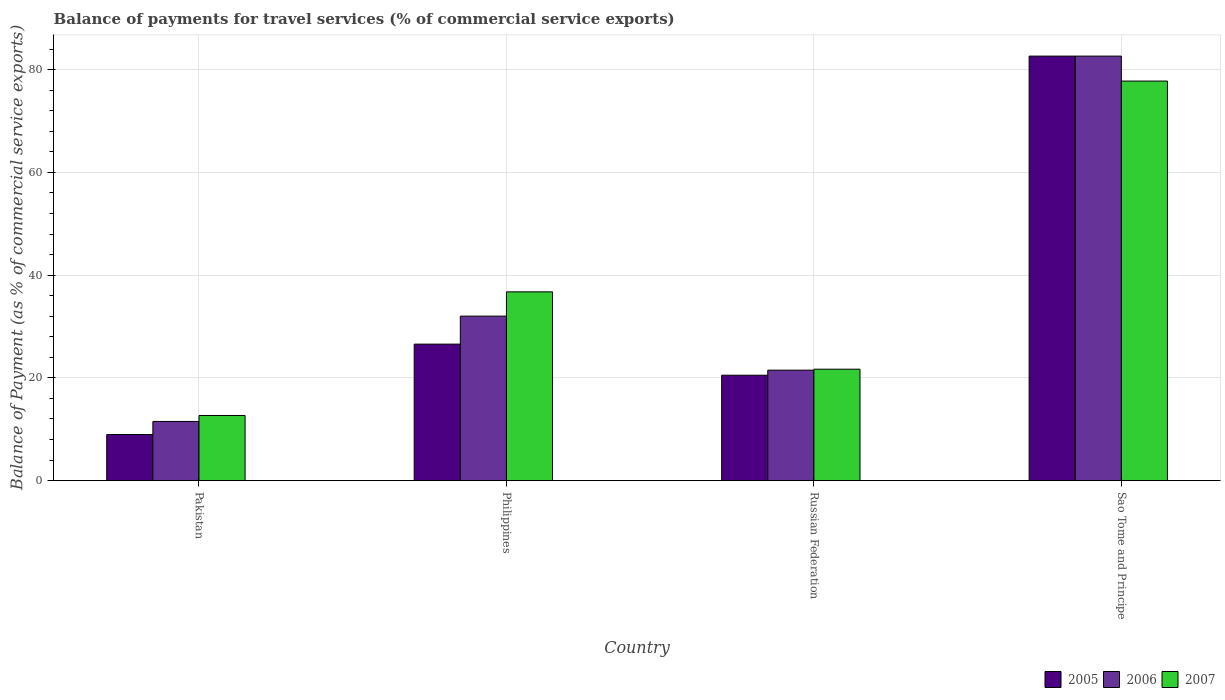How many groups of bars are there?
Provide a succinct answer. 4. Are the number of bars per tick equal to the number of legend labels?
Make the answer very short. Yes. Are the number of bars on each tick of the X-axis equal?
Make the answer very short. Yes. What is the balance of payments for travel services in 2007 in Russian Federation?
Keep it short and to the point. 21.69. Across all countries, what is the maximum balance of payments for travel services in 2005?
Keep it short and to the point. 82.64. Across all countries, what is the minimum balance of payments for travel services in 2007?
Make the answer very short. 12.67. In which country was the balance of payments for travel services in 2006 maximum?
Keep it short and to the point. Sao Tome and Principe. In which country was the balance of payments for travel services in 2007 minimum?
Keep it short and to the point. Pakistan. What is the total balance of payments for travel services in 2006 in the graph?
Your answer should be compact. 147.67. What is the difference between the balance of payments for travel services in 2005 in Philippines and that in Sao Tome and Principe?
Give a very brief answer. -56.08. What is the difference between the balance of payments for travel services in 2005 in Russian Federation and the balance of payments for travel services in 2006 in Sao Tome and Principe?
Offer a terse response. -62.13. What is the average balance of payments for travel services in 2007 per country?
Offer a terse response. 37.22. What is the difference between the balance of payments for travel services of/in 2006 and balance of payments for travel services of/in 2005 in Philippines?
Your response must be concise. 5.45. In how many countries, is the balance of payments for travel services in 2006 greater than 60 %?
Offer a terse response. 1. What is the ratio of the balance of payments for travel services in 2005 in Pakistan to that in Russian Federation?
Keep it short and to the point. 0.44. Is the difference between the balance of payments for travel services in 2006 in Russian Federation and Sao Tome and Principe greater than the difference between the balance of payments for travel services in 2005 in Russian Federation and Sao Tome and Principe?
Offer a terse response. Yes. What is the difference between the highest and the second highest balance of payments for travel services in 2007?
Ensure brevity in your answer.  -15.06. What is the difference between the highest and the lowest balance of payments for travel services in 2007?
Provide a succinct answer. 65.11. In how many countries, is the balance of payments for travel services in 2007 greater than the average balance of payments for travel services in 2007 taken over all countries?
Your answer should be compact. 1. What does the 1st bar from the left in Russian Federation represents?
Give a very brief answer. 2005. Is it the case that in every country, the sum of the balance of payments for travel services in 2006 and balance of payments for travel services in 2005 is greater than the balance of payments for travel services in 2007?
Provide a succinct answer. Yes. How many bars are there?
Give a very brief answer. 12. Does the graph contain any zero values?
Provide a short and direct response. No. How many legend labels are there?
Give a very brief answer. 3. How are the legend labels stacked?
Give a very brief answer. Horizontal. What is the title of the graph?
Give a very brief answer. Balance of payments for travel services (% of commercial service exports). What is the label or title of the Y-axis?
Your answer should be very brief. Balance of Payment (as % of commercial service exports). What is the Balance of Payment (as % of commercial service exports) of 2005 in Pakistan?
Offer a terse response. 8.97. What is the Balance of Payment (as % of commercial service exports) in 2006 in Pakistan?
Make the answer very short. 11.51. What is the Balance of Payment (as % of commercial service exports) of 2007 in Pakistan?
Give a very brief answer. 12.67. What is the Balance of Payment (as % of commercial service exports) in 2005 in Philippines?
Offer a terse response. 26.56. What is the Balance of Payment (as % of commercial service exports) of 2006 in Philippines?
Provide a short and direct response. 32.02. What is the Balance of Payment (as % of commercial service exports) in 2007 in Philippines?
Provide a succinct answer. 36.74. What is the Balance of Payment (as % of commercial service exports) of 2005 in Russian Federation?
Give a very brief answer. 20.51. What is the Balance of Payment (as % of commercial service exports) of 2006 in Russian Federation?
Ensure brevity in your answer.  21.5. What is the Balance of Payment (as % of commercial service exports) of 2007 in Russian Federation?
Provide a short and direct response. 21.69. What is the Balance of Payment (as % of commercial service exports) in 2005 in Sao Tome and Principe?
Offer a very short reply. 82.64. What is the Balance of Payment (as % of commercial service exports) of 2006 in Sao Tome and Principe?
Your answer should be compact. 82.64. What is the Balance of Payment (as % of commercial service exports) of 2007 in Sao Tome and Principe?
Ensure brevity in your answer.  77.78. Across all countries, what is the maximum Balance of Payment (as % of commercial service exports) of 2005?
Your answer should be very brief. 82.64. Across all countries, what is the maximum Balance of Payment (as % of commercial service exports) in 2006?
Offer a terse response. 82.64. Across all countries, what is the maximum Balance of Payment (as % of commercial service exports) of 2007?
Your answer should be very brief. 77.78. Across all countries, what is the minimum Balance of Payment (as % of commercial service exports) in 2005?
Your answer should be compact. 8.97. Across all countries, what is the minimum Balance of Payment (as % of commercial service exports) in 2006?
Keep it short and to the point. 11.51. Across all countries, what is the minimum Balance of Payment (as % of commercial service exports) in 2007?
Ensure brevity in your answer.  12.67. What is the total Balance of Payment (as % of commercial service exports) of 2005 in the graph?
Keep it short and to the point. 138.68. What is the total Balance of Payment (as % of commercial service exports) of 2006 in the graph?
Your answer should be compact. 147.67. What is the total Balance of Payment (as % of commercial service exports) in 2007 in the graph?
Ensure brevity in your answer.  148.89. What is the difference between the Balance of Payment (as % of commercial service exports) in 2005 in Pakistan and that in Philippines?
Your response must be concise. -17.6. What is the difference between the Balance of Payment (as % of commercial service exports) in 2006 in Pakistan and that in Philippines?
Your answer should be very brief. -20.5. What is the difference between the Balance of Payment (as % of commercial service exports) of 2007 in Pakistan and that in Philippines?
Ensure brevity in your answer.  -24.07. What is the difference between the Balance of Payment (as % of commercial service exports) of 2005 in Pakistan and that in Russian Federation?
Ensure brevity in your answer.  -11.55. What is the difference between the Balance of Payment (as % of commercial service exports) of 2006 in Pakistan and that in Russian Federation?
Give a very brief answer. -9.98. What is the difference between the Balance of Payment (as % of commercial service exports) in 2007 in Pakistan and that in Russian Federation?
Offer a very short reply. -9.01. What is the difference between the Balance of Payment (as % of commercial service exports) of 2005 in Pakistan and that in Sao Tome and Principe?
Give a very brief answer. -73.68. What is the difference between the Balance of Payment (as % of commercial service exports) of 2006 in Pakistan and that in Sao Tome and Principe?
Keep it short and to the point. -71.13. What is the difference between the Balance of Payment (as % of commercial service exports) of 2007 in Pakistan and that in Sao Tome and Principe?
Your answer should be compact. -65.11. What is the difference between the Balance of Payment (as % of commercial service exports) of 2005 in Philippines and that in Russian Federation?
Provide a short and direct response. 6.05. What is the difference between the Balance of Payment (as % of commercial service exports) in 2006 in Philippines and that in Russian Federation?
Ensure brevity in your answer.  10.52. What is the difference between the Balance of Payment (as % of commercial service exports) of 2007 in Philippines and that in Russian Federation?
Keep it short and to the point. 15.06. What is the difference between the Balance of Payment (as % of commercial service exports) of 2005 in Philippines and that in Sao Tome and Principe?
Ensure brevity in your answer.  -56.08. What is the difference between the Balance of Payment (as % of commercial service exports) in 2006 in Philippines and that in Sao Tome and Principe?
Provide a short and direct response. -50.63. What is the difference between the Balance of Payment (as % of commercial service exports) of 2007 in Philippines and that in Sao Tome and Principe?
Offer a terse response. -41.04. What is the difference between the Balance of Payment (as % of commercial service exports) in 2005 in Russian Federation and that in Sao Tome and Principe?
Keep it short and to the point. -62.13. What is the difference between the Balance of Payment (as % of commercial service exports) in 2006 in Russian Federation and that in Sao Tome and Principe?
Give a very brief answer. -61.15. What is the difference between the Balance of Payment (as % of commercial service exports) in 2007 in Russian Federation and that in Sao Tome and Principe?
Your response must be concise. -56.1. What is the difference between the Balance of Payment (as % of commercial service exports) in 2005 in Pakistan and the Balance of Payment (as % of commercial service exports) in 2006 in Philippines?
Give a very brief answer. -23.05. What is the difference between the Balance of Payment (as % of commercial service exports) of 2005 in Pakistan and the Balance of Payment (as % of commercial service exports) of 2007 in Philippines?
Provide a succinct answer. -27.78. What is the difference between the Balance of Payment (as % of commercial service exports) in 2006 in Pakistan and the Balance of Payment (as % of commercial service exports) in 2007 in Philippines?
Offer a very short reply. -25.23. What is the difference between the Balance of Payment (as % of commercial service exports) of 2005 in Pakistan and the Balance of Payment (as % of commercial service exports) of 2006 in Russian Federation?
Make the answer very short. -12.53. What is the difference between the Balance of Payment (as % of commercial service exports) of 2005 in Pakistan and the Balance of Payment (as % of commercial service exports) of 2007 in Russian Federation?
Give a very brief answer. -12.72. What is the difference between the Balance of Payment (as % of commercial service exports) in 2006 in Pakistan and the Balance of Payment (as % of commercial service exports) in 2007 in Russian Federation?
Offer a very short reply. -10.17. What is the difference between the Balance of Payment (as % of commercial service exports) of 2005 in Pakistan and the Balance of Payment (as % of commercial service exports) of 2006 in Sao Tome and Principe?
Your answer should be compact. -73.68. What is the difference between the Balance of Payment (as % of commercial service exports) of 2005 in Pakistan and the Balance of Payment (as % of commercial service exports) of 2007 in Sao Tome and Principe?
Your answer should be compact. -68.82. What is the difference between the Balance of Payment (as % of commercial service exports) in 2006 in Pakistan and the Balance of Payment (as % of commercial service exports) in 2007 in Sao Tome and Principe?
Keep it short and to the point. -66.27. What is the difference between the Balance of Payment (as % of commercial service exports) in 2005 in Philippines and the Balance of Payment (as % of commercial service exports) in 2006 in Russian Federation?
Offer a terse response. 5.07. What is the difference between the Balance of Payment (as % of commercial service exports) in 2005 in Philippines and the Balance of Payment (as % of commercial service exports) in 2007 in Russian Federation?
Make the answer very short. 4.88. What is the difference between the Balance of Payment (as % of commercial service exports) in 2006 in Philippines and the Balance of Payment (as % of commercial service exports) in 2007 in Russian Federation?
Provide a short and direct response. 10.33. What is the difference between the Balance of Payment (as % of commercial service exports) in 2005 in Philippines and the Balance of Payment (as % of commercial service exports) in 2006 in Sao Tome and Principe?
Keep it short and to the point. -56.08. What is the difference between the Balance of Payment (as % of commercial service exports) in 2005 in Philippines and the Balance of Payment (as % of commercial service exports) in 2007 in Sao Tome and Principe?
Give a very brief answer. -51.22. What is the difference between the Balance of Payment (as % of commercial service exports) in 2006 in Philippines and the Balance of Payment (as % of commercial service exports) in 2007 in Sao Tome and Principe?
Your answer should be very brief. -45.77. What is the difference between the Balance of Payment (as % of commercial service exports) in 2005 in Russian Federation and the Balance of Payment (as % of commercial service exports) in 2006 in Sao Tome and Principe?
Provide a short and direct response. -62.13. What is the difference between the Balance of Payment (as % of commercial service exports) of 2005 in Russian Federation and the Balance of Payment (as % of commercial service exports) of 2007 in Sao Tome and Principe?
Your answer should be very brief. -57.27. What is the difference between the Balance of Payment (as % of commercial service exports) in 2006 in Russian Federation and the Balance of Payment (as % of commercial service exports) in 2007 in Sao Tome and Principe?
Your response must be concise. -56.29. What is the average Balance of Payment (as % of commercial service exports) of 2005 per country?
Provide a succinct answer. 34.67. What is the average Balance of Payment (as % of commercial service exports) in 2006 per country?
Ensure brevity in your answer.  36.92. What is the average Balance of Payment (as % of commercial service exports) in 2007 per country?
Your answer should be very brief. 37.22. What is the difference between the Balance of Payment (as % of commercial service exports) of 2005 and Balance of Payment (as % of commercial service exports) of 2006 in Pakistan?
Make the answer very short. -2.55. What is the difference between the Balance of Payment (as % of commercial service exports) of 2005 and Balance of Payment (as % of commercial service exports) of 2007 in Pakistan?
Your answer should be compact. -3.71. What is the difference between the Balance of Payment (as % of commercial service exports) in 2006 and Balance of Payment (as % of commercial service exports) in 2007 in Pakistan?
Your answer should be very brief. -1.16. What is the difference between the Balance of Payment (as % of commercial service exports) in 2005 and Balance of Payment (as % of commercial service exports) in 2006 in Philippines?
Your answer should be compact. -5.45. What is the difference between the Balance of Payment (as % of commercial service exports) of 2005 and Balance of Payment (as % of commercial service exports) of 2007 in Philippines?
Provide a succinct answer. -10.18. What is the difference between the Balance of Payment (as % of commercial service exports) of 2006 and Balance of Payment (as % of commercial service exports) of 2007 in Philippines?
Provide a short and direct response. -4.73. What is the difference between the Balance of Payment (as % of commercial service exports) in 2005 and Balance of Payment (as % of commercial service exports) in 2006 in Russian Federation?
Offer a very short reply. -0.99. What is the difference between the Balance of Payment (as % of commercial service exports) of 2005 and Balance of Payment (as % of commercial service exports) of 2007 in Russian Federation?
Provide a short and direct response. -1.17. What is the difference between the Balance of Payment (as % of commercial service exports) in 2006 and Balance of Payment (as % of commercial service exports) in 2007 in Russian Federation?
Offer a very short reply. -0.19. What is the difference between the Balance of Payment (as % of commercial service exports) in 2005 and Balance of Payment (as % of commercial service exports) in 2006 in Sao Tome and Principe?
Keep it short and to the point. -0. What is the difference between the Balance of Payment (as % of commercial service exports) of 2005 and Balance of Payment (as % of commercial service exports) of 2007 in Sao Tome and Principe?
Offer a very short reply. 4.86. What is the difference between the Balance of Payment (as % of commercial service exports) of 2006 and Balance of Payment (as % of commercial service exports) of 2007 in Sao Tome and Principe?
Your answer should be very brief. 4.86. What is the ratio of the Balance of Payment (as % of commercial service exports) in 2005 in Pakistan to that in Philippines?
Offer a very short reply. 0.34. What is the ratio of the Balance of Payment (as % of commercial service exports) of 2006 in Pakistan to that in Philippines?
Give a very brief answer. 0.36. What is the ratio of the Balance of Payment (as % of commercial service exports) of 2007 in Pakistan to that in Philippines?
Keep it short and to the point. 0.34. What is the ratio of the Balance of Payment (as % of commercial service exports) of 2005 in Pakistan to that in Russian Federation?
Your answer should be very brief. 0.44. What is the ratio of the Balance of Payment (as % of commercial service exports) in 2006 in Pakistan to that in Russian Federation?
Your answer should be compact. 0.54. What is the ratio of the Balance of Payment (as % of commercial service exports) in 2007 in Pakistan to that in Russian Federation?
Make the answer very short. 0.58. What is the ratio of the Balance of Payment (as % of commercial service exports) in 2005 in Pakistan to that in Sao Tome and Principe?
Ensure brevity in your answer.  0.11. What is the ratio of the Balance of Payment (as % of commercial service exports) in 2006 in Pakistan to that in Sao Tome and Principe?
Your answer should be compact. 0.14. What is the ratio of the Balance of Payment (as % of commercial service exports) in 2007 in Pakistan to that in Sao Tome and Principe?
Your answer should be very brief. 0.16. What is the ratio of the Balance of Payment (as % of commercial service exports) of 2005 in Philippines to that in Russian Federation?
Offer a very short reply. 1.3. What is the ratio of the Balance of Payment (as % of commercial service exports) of 2006 in Philippines to that in Russian Federation?
Offer a terse response. 1.49. What is the ratio of the Balance of Payment (as % of commercial service exports) in 2007 in Philippines to that in Russian Federation?
Make the answer very short. 1.69. What is the ratio of the Balance of Payment (as % of commercial service exports) in 2005 in Philippines to that in Sao Tome and Principe?
Your response must be concise. 0.32. What is the ratio of the Balance of Payment (as % of commercial service exports) in 2006 in Philippines to that in Sao Tome and Principe?
Provide a short and direct response. 0.39. What is the ratio of the Balance of Payment (as % of commercial service exports) of 2007 in Philippines to that in Sao Tome and Principe?
Your response must be concise. 0.47. What is the ratio of the Balance of Payment (as % of commercial service exports) of 2005 in Russian Federation to that in Sao Tome and Principe?
Your answer should be compact. 0.25. What is the ratio of the Balance of Payment (as % of commercial service exports) of 2006 in Russian Federation to that in Sao Tome and Principe?
Your answer should be compact. 0.26. What is the ratio of the Balance of Payment (as % of commercial service exports) in 2007 in Russian Federation to that in Sao Tome and Principe?
Ensure brevity in your answer.  0.28. What is the difference between the highest and the second highest Balance of Payment (as % of commercial service exports) of 2005?
Keep it short and to the point. 56.08. What is the difference between the highest and the second highest Balance of Payment (as % of commercial service exports) in 2006?
Your response must be concise. 50.63. What is the difference between the highest and the second highest Balance of Payment (as % of commercial service exports) in 2007?
Your answer should be compact. 41.04. What is the difference between the highest and the lowest Balance of Payment (as % of commercial service exports) in 2005?
Your response must be concise. 73.68. What is the difference between the highest and the lowest Balance of Payment (as % of commercial service exports) of 2006?
Provide a succinct answer. 71.13. What is the difference between the highest and the lowest Balance of Payment (as % of commercial service exports) of 2007?
Make the answer very short. 65.11. 